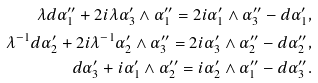Convert formula to latex. <formula><loc_0><loc_0><loc_500><loc_500>\lambda d \alpha _ { 1 } ^ { \prime \prime } + 2 i \lambda \alpha _ { 3 } ^ { \prime } \wedge \alpha _ { 1 } ^ { \prime \prime } = 2 i \alpha _ { 1 } ^ { \prime } \wedge \alpha _ { 3 } ^ { \prime \prime } - d \alpha _ { 1 } ^ { \prime } & , \\ \lambda ^ { - 1 } d \alpha _ { 2 } ^ { \prime } + 2 i \lambda ^ { - 1 } \alpha _ { 2 } ^ { \prime } \wedge \alpha _ { 3 } ^ { \prime \prime } = 2 i \alpha _ { 3 } ^ { \prime } \wedge \alpha _ { 2 } ^ { \prime \prime } - d \alpha _ { 2 } ^ { \prime \prime } & , \\ d \alpha _ { 3 } ^ { \prime } + i \alpha _ { 1 } ^ { \prime } \wedge \alpha _ { 2 } ^ { \prime \prime } = i \alpha _ { 2 } ^ { \prime } \wedge \alpha _ { 1 } ^ { \prime \prime } - d \alpha _ { 3 } ^ { \prime \prime } & .</formula> 